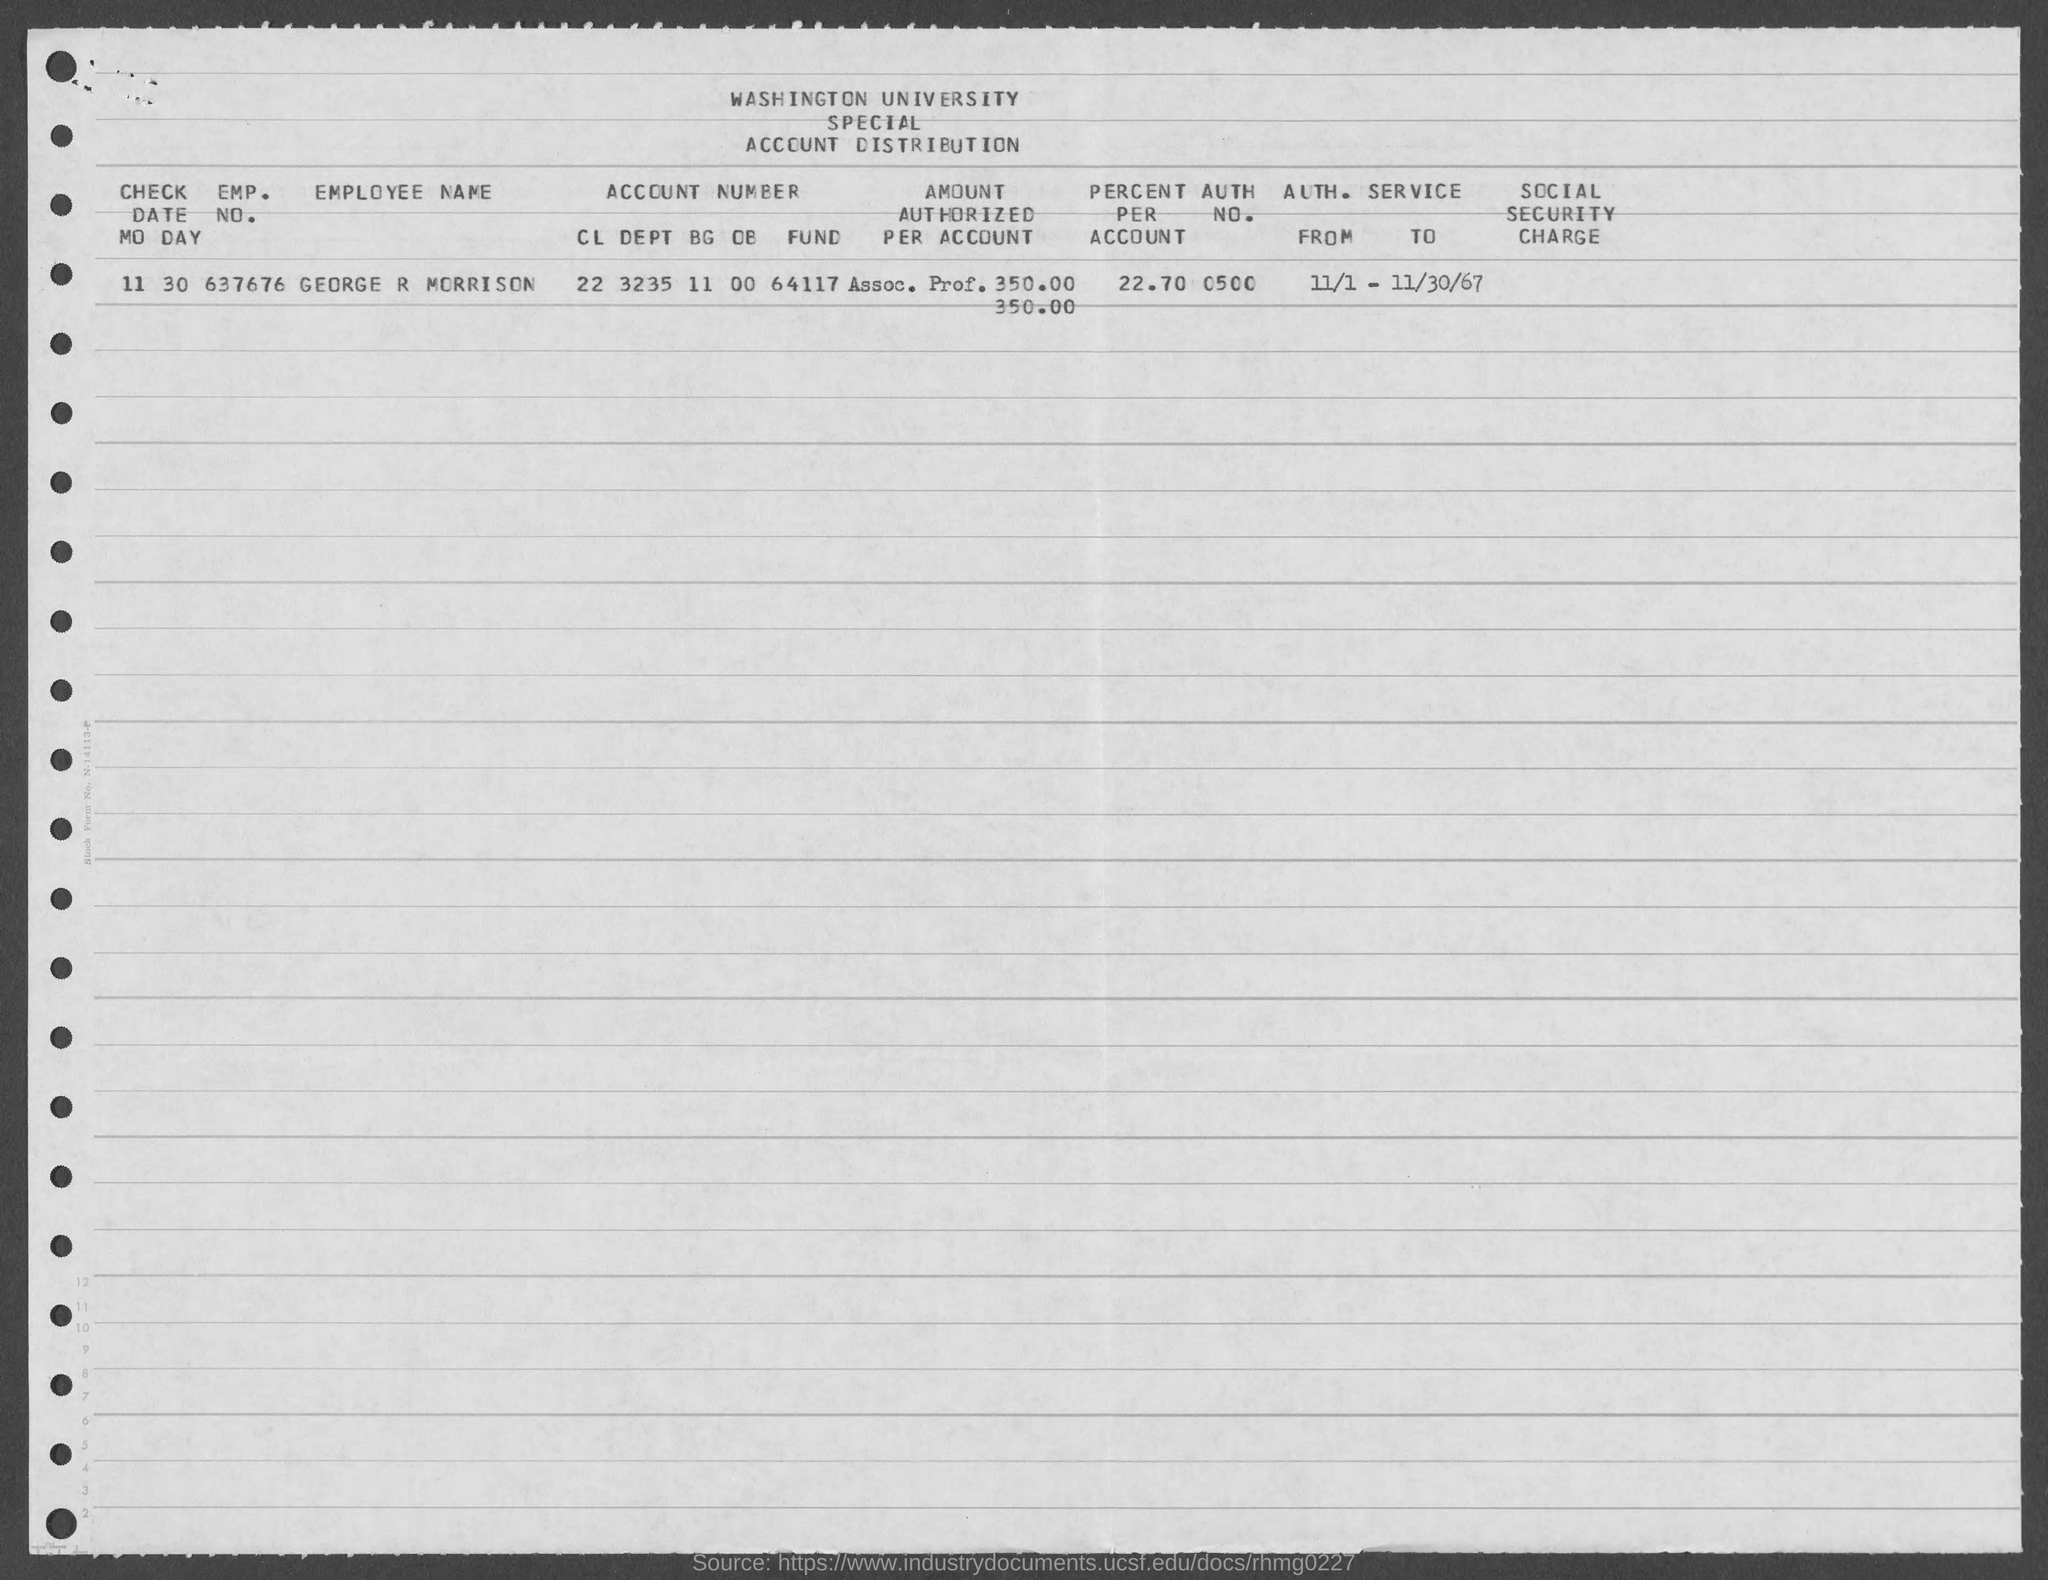Specify some key components in this picture. The value of the percentage as mentioned in the given form is 22.70%. I'm sorry, but the given text does not contain a complete question that requires a response. It is difficult to determine what the question is asking without additional context or information. Can you please provide more information or clarify the question? The authorized number mentioned in the given form is 0500... The check date mentioned in the given form is 11/30. What is the name of the university mentioned in the given form? The university is Washington University. 